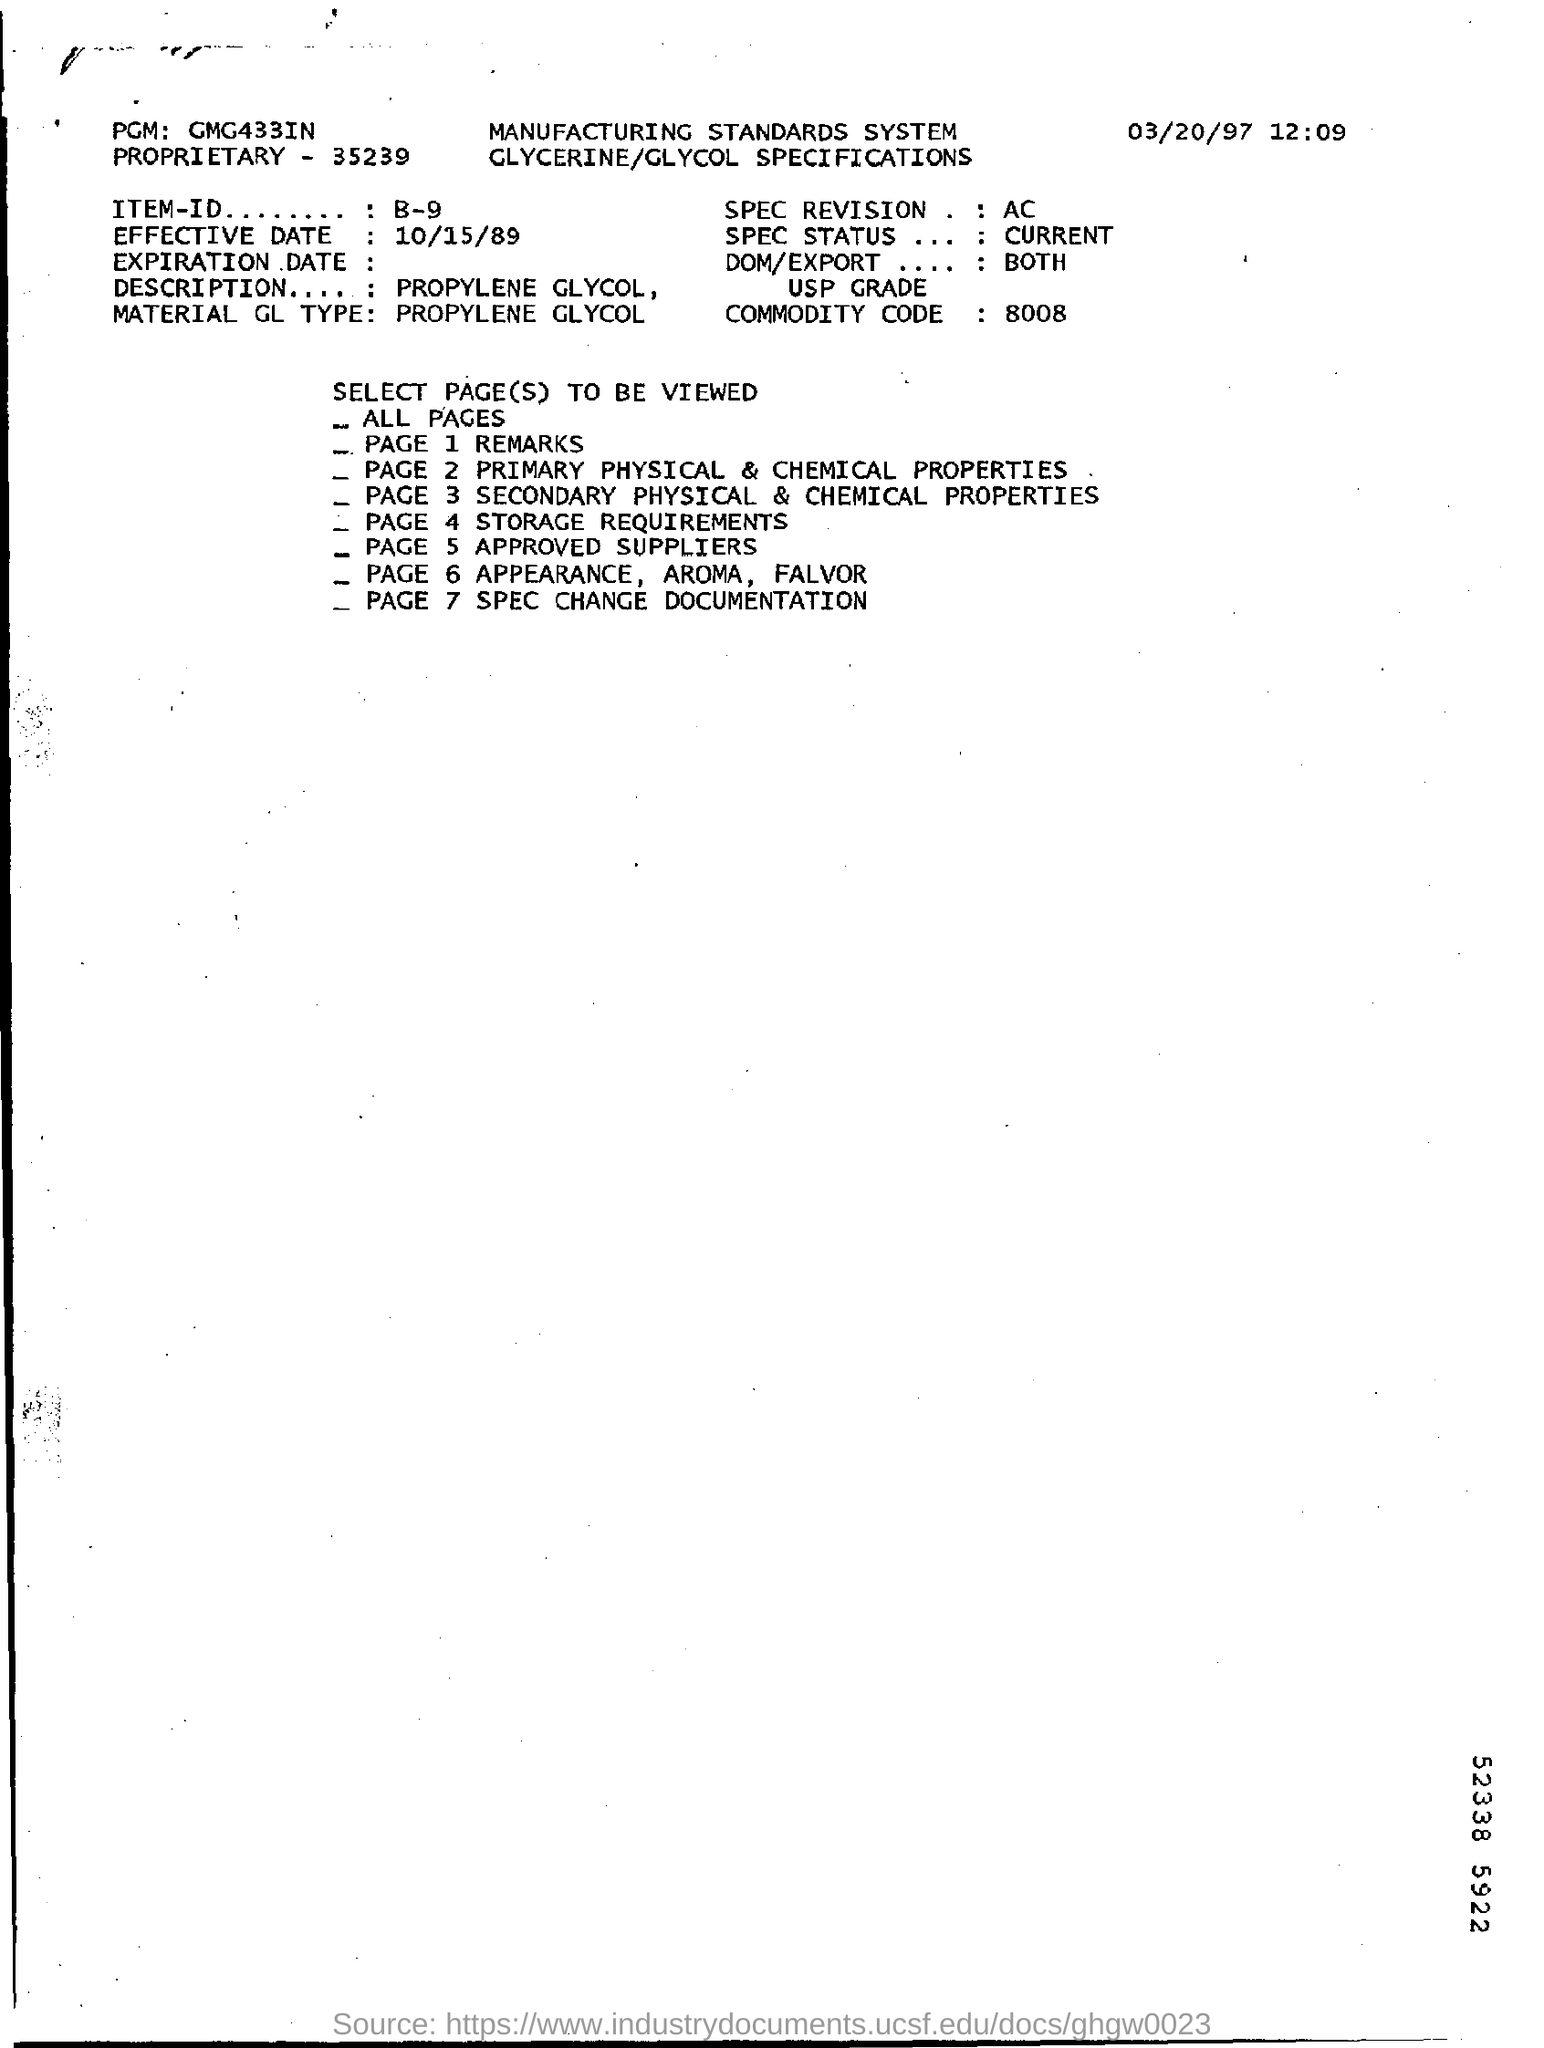Specify some key components in this picture. The material is propylene glycol. The Commodity Code mentioned in the document is 8008. The effective date of this document is 10/15/89. What is the ITEM-ID given?" is a question asking for information about a specific item. It is often used in technical or business contexts to request details about a particular item or object. For example, "Can you please provide me with the ITEM-ID for B-9?" is a clear and concise way to ask for information about B-9. The topic of approved suppliers is discussed on page 5 of this document. 